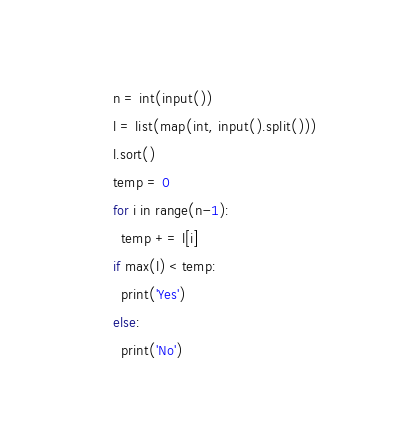<code> <loc_0><loc_0><loc_500><loc_500><_Python_>n = int(input())
l = list(map(int, input().split()))
l.sort()
temp = 0
for i in range(n-1):
  temp += l[i]
if max(l) < temp:
  print('Yes')
else:
  print('No')</code> 